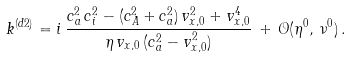Convert formula to latex. <formula><loc_0><loc_0><loc_500><loc_500>k ^ { ( d 2 ) } = i \, \frac { c _ { a } ^ { 2 } \, c _ { i } ^ { 2 } - ( c _ { A } ^ { 2 } + c _ { a } ^ { 2 } ) \, v _ { x , 0 } ^ { 2 } + v _ { x , 0 } ^ { 4 } } { \eta \, v _ { x , 0 } \, ( c _ { a } ^ { 2 } - v _ { x , 0 } ^ { 2 } ) } \, + \, \mathcal { O } ( \eta ^ { 0 } , \, \nu ^ { 0 } ) \, .</formula> 